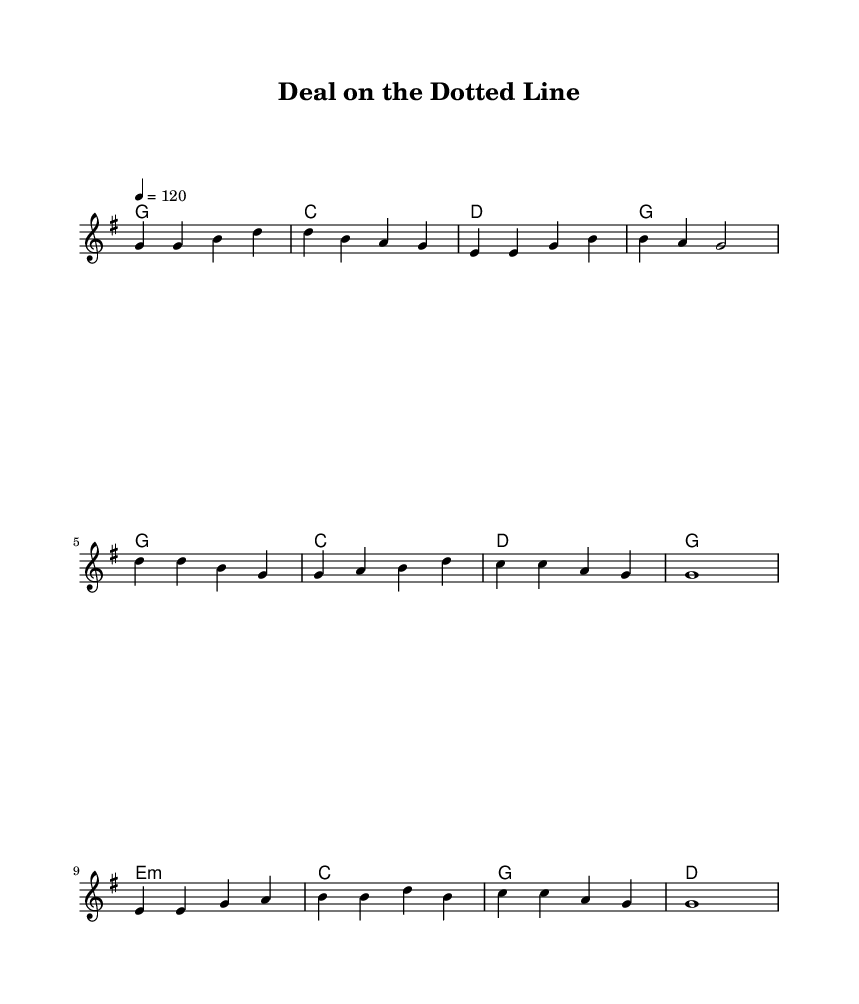What is the key signature of this music? The key signature is G major, which has one sharp (F#).
Answer: G major What is the time signature of this music? The time signature is 4/4, indicating four beats per measure.
Answer: 4/4 What is the tempo marking for this piece? The tempo marking indicates a speed of 120 beats per minute.
Answer: 120 How many measures are in the verse? The verse has four measures, as indicated by the melody lines in the sheet music.
Answer: Four measures In which section does the lyric "Sign on the dotted line" appear? This lyric appears in the chorus section of the song.
Answer: Chorus What type of chords are primarily used in the harmony section? The harmony section primarily uses major chords, indicating a bright, upbeat feel typical of country rock.
Answer: Major chords How does the structure of this song relate to traditional country rock? The song follows a typical country rock structure with verses, a chorus, and a bridge, emphasizing relatable themes of negotiation and deals in real estate.
Answer: Verse-Chorus-Bridge structure 